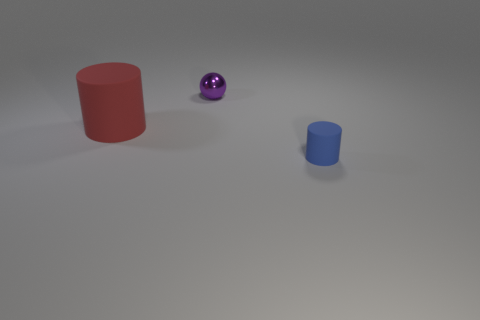Add 2 tiny gray metallic spheres. How many objects exist? 5 Subtract all spheres. How many objects are left? 2 Subtract 0 cyan balls. How many objects are left? 3 Subtract all small red rubber cylinders. Subtract all tiny shiny spheres. How many objects are left? 2 Add 3 red things. How many red things are left? 4 Add 1 purple metal objects. How many purple metal objects exist? 2 